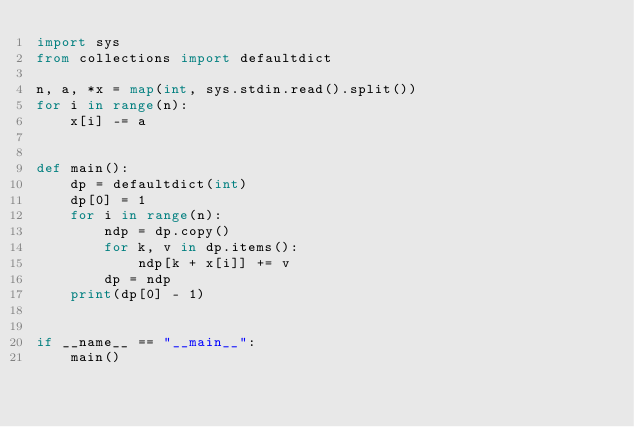<code> <loc_0><loc_0><loc_500><loc_500><_Python_>import sys
from collections import defaultdict

n, a, *x = map(int, sys.stdin.read().split())
for i in range(n):
    x[i] -= a


def main():
    dp = defaultdict(int)
    dp[0] = 1
    for i in range(n):
        ndp = dp.copy()
        for k, v in dp.items():
            ndp[k + x[i]] += v
        dp = ndp
    print(dp[0] - 1)


if __name__ == "__main__":
    main()
</code> 